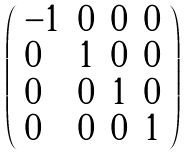<formula> <loc_0><loc_0><loc_500><loc_500>\left ( \begin{array} { l l l l } { - 1 } & { 0 } & { 0 } & { 0 } \\ { 0 } & { 1 } & { 0 } & { 0 } \\ { 0 } & { 0 } & { 1 } & { 0 } \\ { 0 } & { 0 } & { 0 } & { 1 } \end{array} \right )</formula> 